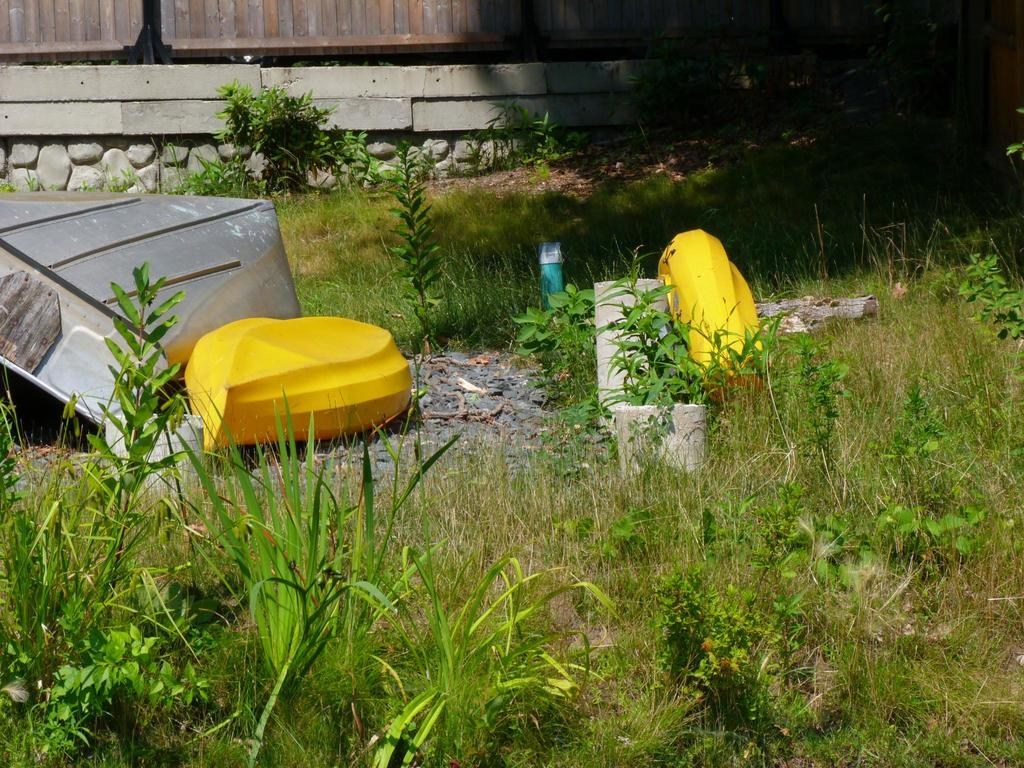What type of vegetation covers the land in the image? The land in the image is covered with plants and trees. What can be seen on the left side of the image? There appears to be a boat on the left side of the image. What is visible in the background of the image? There is a wall visible in the background of the image. What type of hair can be seen on the boat in the image? There is no hair present on the boat in the image. Is there an umbrella being used by anyone in the image? There is no umbrella visible in the image. 